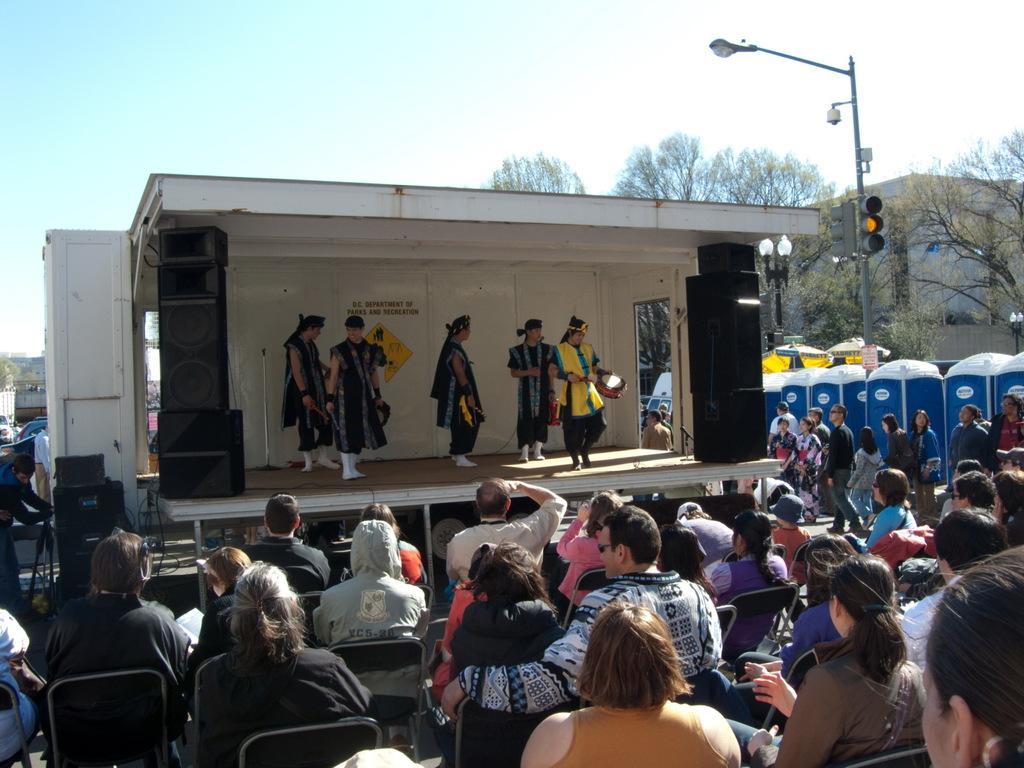What are the people in the image doing? The people in the image are sitting on chairs. Where are the people sitting in the image? Some people are on a stage in the image. What can be seen in the background of the image? In the background of the image, there are traffic signals, poles, trees, and a building. What type of book is being read by the eye in the image? There is no eye or book present in the image. 